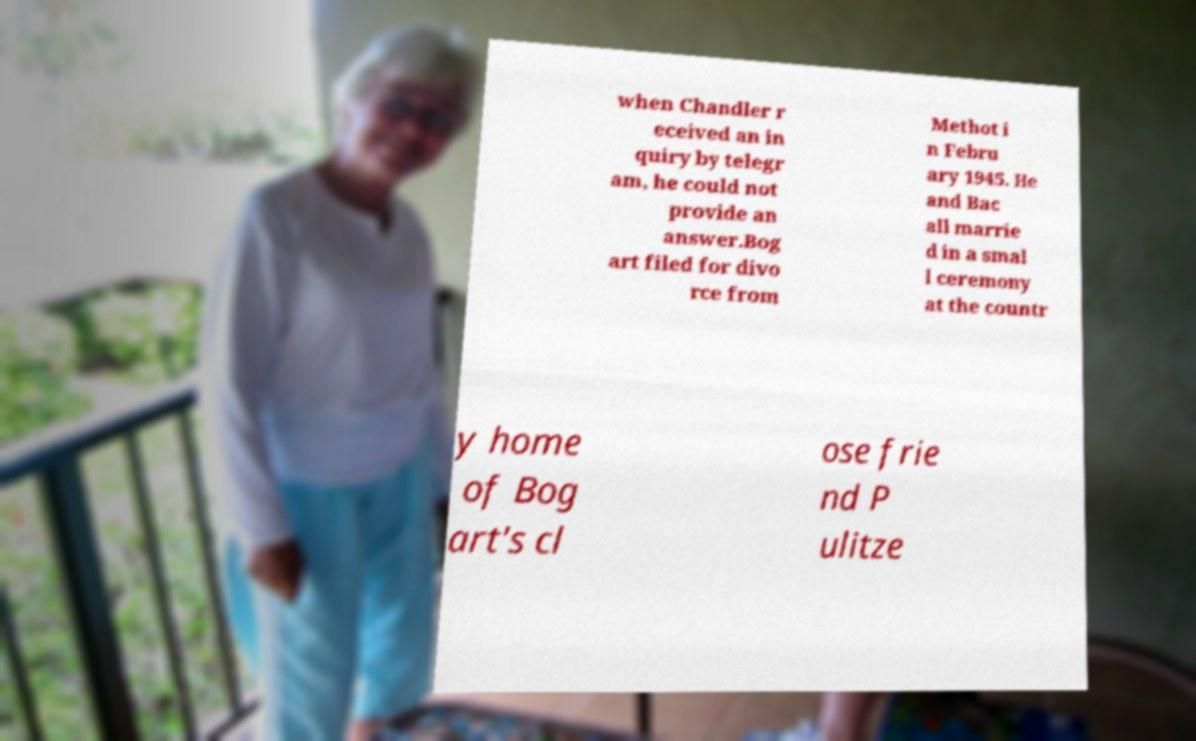There's text embedded in this image that I need extracted. Can you transcribe it verbatim? when Chandler r eceived an in quiry by telegr am, he could not provide an answer.Bog art filed for divo rce from Methot i n Febru ary 1945. He and Bac all marrie d in a smal l ceremony at the countr y home of Bog art's cl ose frie nd P ulitze 